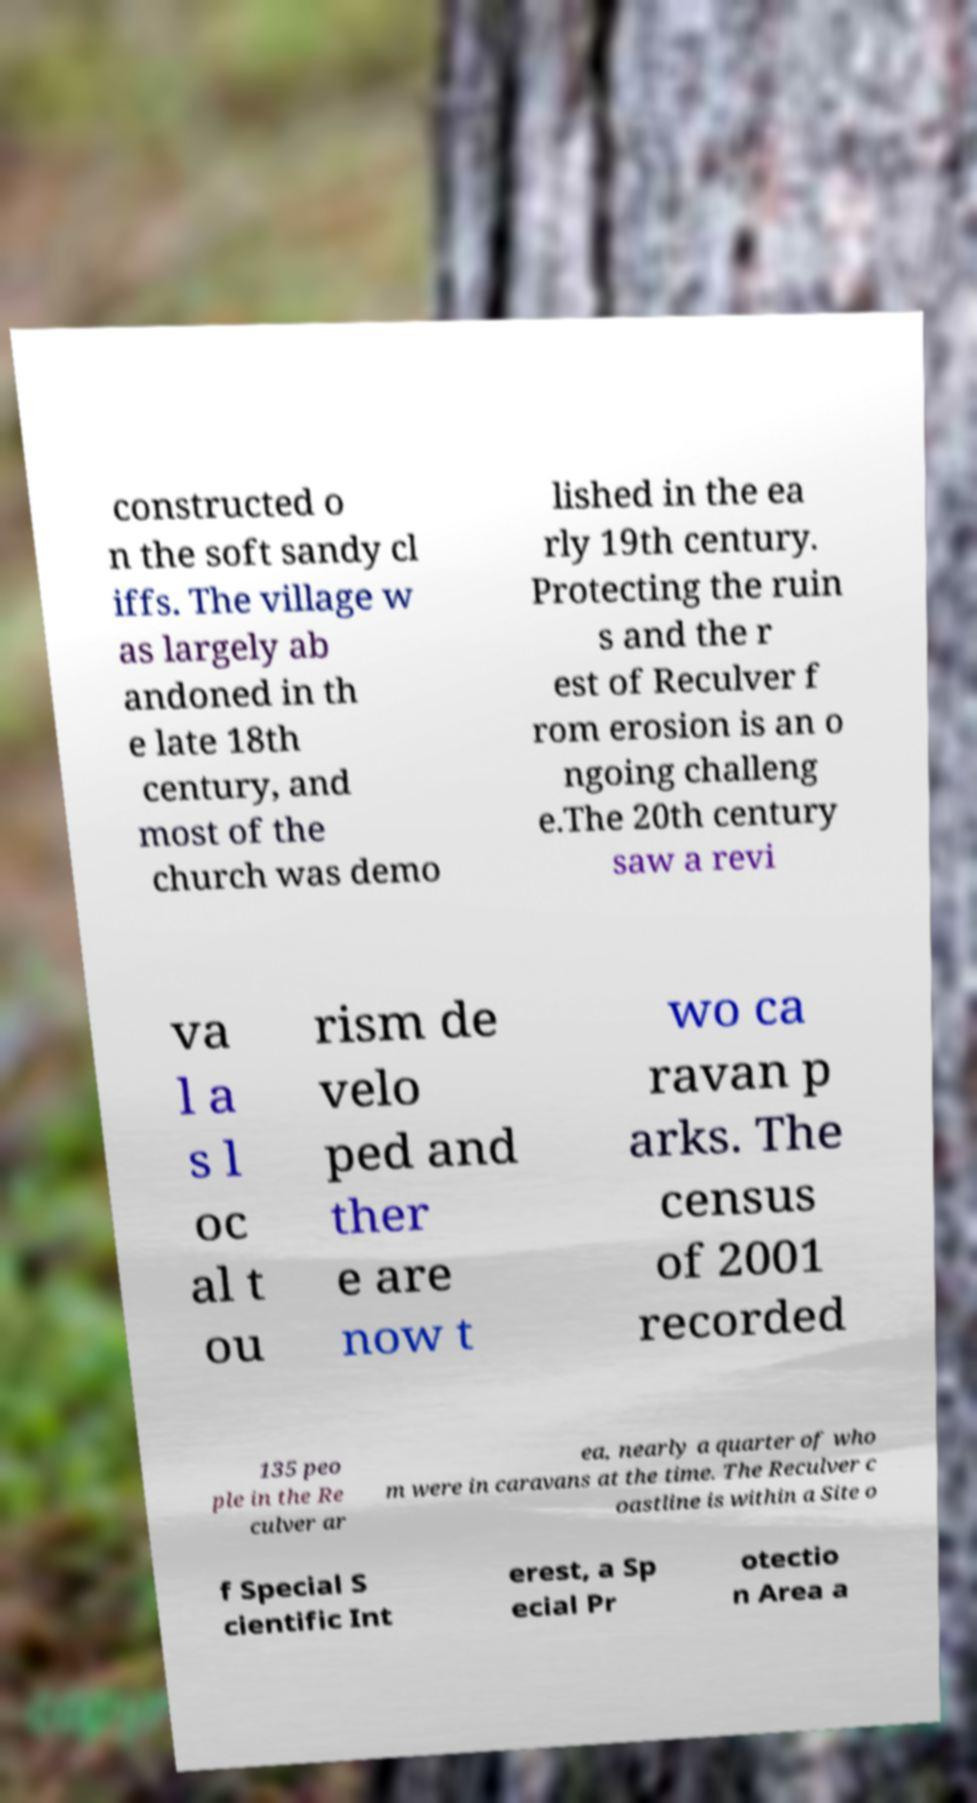I need the written content from this picture converted into text. Can you do that? constructed o n the soft sandy cl iffs. The village w as largely ab andoned in th e late 18th century, and most of the church was demo lished in the ea rly 19th century. Protecting the ruin s and the r est of Reculver f rom erosion is an o ngoing challeng e.The 20th century saw a revi va l a s l oc al t ou rism de velo ped and ther e are now t wo ca ravan p arks. The census of 2001 recorded 135 peo ple in the Re culver ar ea, nearly a quarter of who m were in caravans at the time. The Reculver c oastline is within a Site o f Special S cientific Int erest, a Sp ecial Pr otectio n Area a 